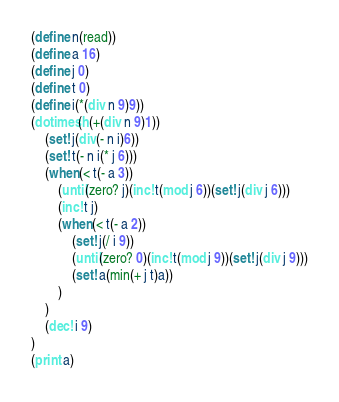Convert code to text. <code><loc_0><loc_0><loc_500><loc_500><_Scheme_>(define n(read))
(define a 16)
(define j 0)
(define t 0)
(define i(*(div n 9)9))
(dotimes(h(+(div n 9)1))
	(set! j(div(- n i)6))
	(set! t(- n i(* j 6)))
	(when(< t(- a 3))
		(until(zero? j)(inc! t(mod j 6))(set! j(div j 6)))
		(inc! t j)
		(when(< t(- a 2))
			(set! j(/ i 9))
			(until(zero? 0)(inc! t(mod j 9))(set! j(div j 9)))
			(set! a(min(+ j t)a))
		)
	)
	(dec! i 9)
)
(print a)</code> 